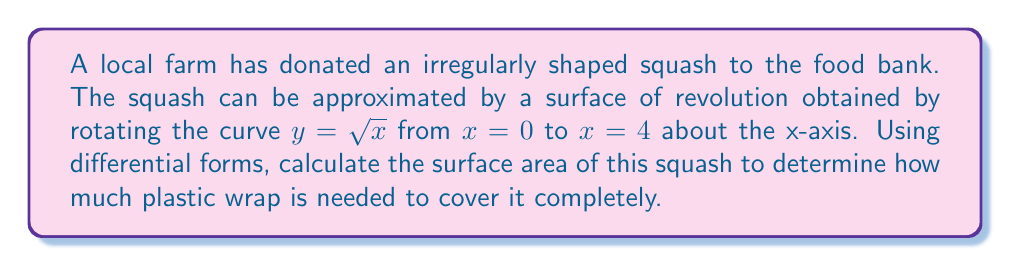Provide a solution to this math problem. To solve this problem, we'll use the surface area formula for a surface of revolution using differential forms. The steps are as follows:

1) The surface area of a surface of revolution is given by the integral:

   $$A = \int_M \omega$$

   where $\omega$ is the area form on the surface.

2) For a surface of revolution, the area form is:

   $$\omega = 2\pi y \sqrt{1 + (y')^2} dx$$

3) In our case, $y = \sqrt{x}$, so $y' = \frac{1}{2\sqrt{x}}$

4) Substituting these into the area form:

   $$\omega = 2\pi \sqrt{x} \sqrt{1 + (\frac{1}{2\sqrt{x}})^2} dx$$

5) Simplify under the square root:

   $$\omega = 2\pi \sqrt{x} \sqrt{1 + \frac{1}{4x}} dx$$

6) Now we integrate from $x = 0$ to $x = 4$:

   $$A = \int_0^4 2\pi \sqrt{x} \sqrt{1 + \frac{1}{4x}} dx$$

7) This integral is quite complex. We can solve it using the substitution $u = \sqrt{x}$, which gives $x = u^2$ and $dx = 2u du$. The limits change to $u = 0$ and $u = 2$:

   $$A = \int_0^2 2\pi u \sqrt{1 + \frac{1}{4u^2}} (2u du)$$

8) Simplify:

   $$A = 4\pi \int_0^2 u^2 \sqrt{1 + \frac{1}{4u^2}} du$$

9) This integral can be solved using hyperbolic functions, resulting in:

   $$A = 4\pi [\frac{u^3}{3}\sqrt{1 + \frac{1}{4u^2}} + \frac{1}{6}\ln(2u + \sqrt{4u^2 + 1})]_0^2$$

10) Evaluating at the limits:

    $$A = 4\pi [\frac{8}{3}\sqrt{1 + \frac{1}{16}} + \frac{1}{6}\ln(4 + \sqrt{17}) - 0]$$

11) Simplify:

    $$A = 4\pi [\frac{8}{3}\sqrt{\frac{17}{16}} + \frac{1}{6}\ln(4 + \sqrt{17})]$$

12) Calculate the numerical value:

    $$A \approx 33.51 \text{ square units}$$
Answer: $33.51 \text{ square units}$ 